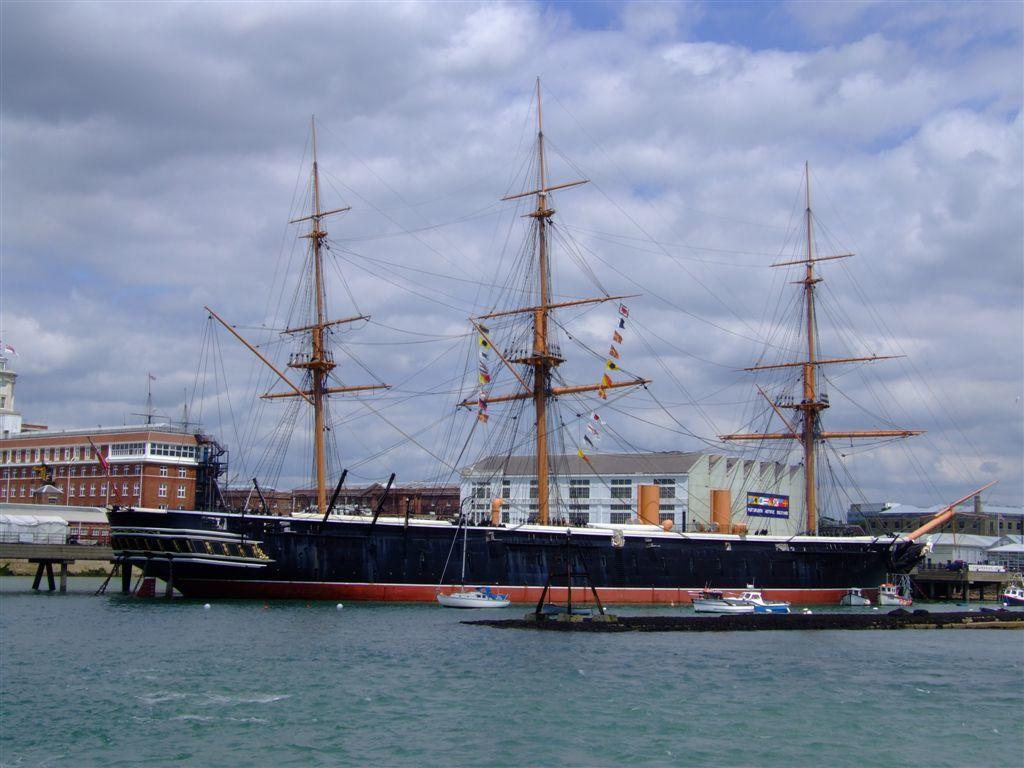What is the main subject of the image? The main subject of the image is water. What other objects can be seen in the water? There is a ship and boats in the water. What structures are present in the image? There is a bridge and buildings in the image. What is visible in the background of the image? The sky is visible in the background of the image, and it is cloudy. What additional objects can be seen in the image? There are rods and flags in the image. What type of orange is being peeled on the coast in the image? There is no orange or coast present in the image; it features water, a ship, boats, a bridge, buildings, a cloudy sky, rods, and flags. 